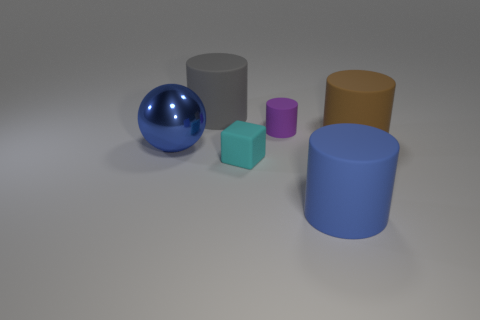Subtract all green cylinders. Subtract all brown balls. How many cylinders are left? 4 Add 2 large blue balls. How many objects exist? 8 Subtract all cylinders. How many objects are left? 2 Subtract all gray rubber cylinders. Subtract all big matte cylinders. How many objects are left? 2 Add 2 large shiny balls. How many large shiny balls are left? 3 Add 5 tiny rubber cylinders. How many tiny rubber cylinders exist? 6 Subtract 0 gray blocks. How many objects are left? 6 